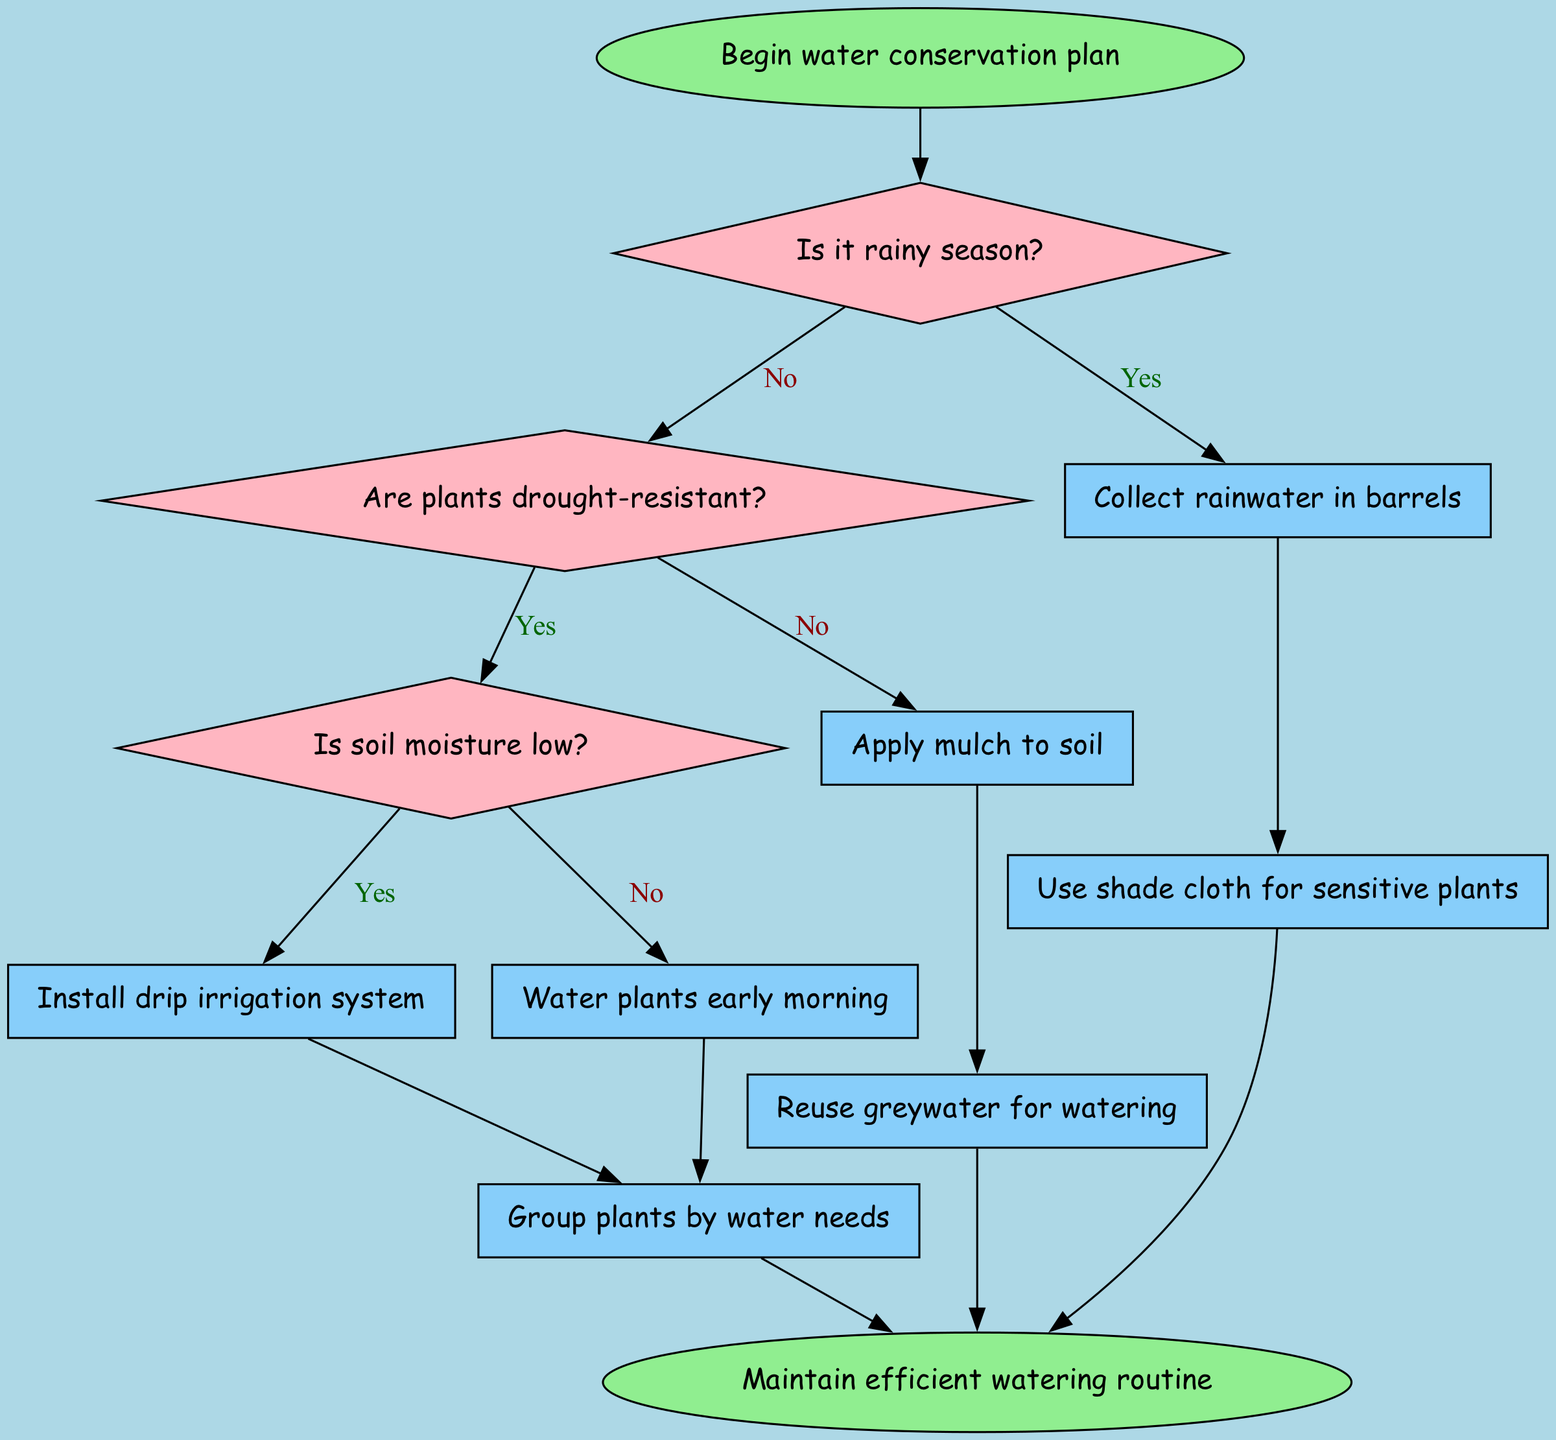What is the first action to be taken if it is the rainy season? The diagram indicates that if it is the rainy season, the first action to be taken is to collect rainwater in barrels. This is shown directly after the decision node for the rainy season which leads to this action.
Answer: Collect rainwater in barrels How many decision nodes are present in the flowchart? The flowchart has three decision nodes: "Is it rainy season?", "Are plants drought-resistant?", and "Is soil moisture low?". The count of these nodes gives the total number of decision points in the flowchart.
Answer: Three What happens if the soil moisture is low and the plants are not drought-resistant? The flowchart specifies that if the soil moisture is low and the plants are not drought-resistant, the next action taken is to reuse greywater for watering. This can be traced through the decision nodes leading to this action.
Answer: Reuse greywater for watering How many total actions are listed in the flowchart? The flowchart contains a total of seven actions: collect rainwater in barrels, apply mulch to soil, install drip irrigation system, water plants early morning, use shade cloth for sensitive plants, reuse greywater for watering, and group plants by water needs. The total is obtained by counting all the listed actions in the diagram.
Answer: Seven What action is recommended after watering plants early in the morning? According to the flowchart, after watering plants early in the morning, the next recommended action is to reuse greywater for watering. This is illustrated as the direct connection from that action node in the flowchart.
Answer: Reuse greywater for watering 